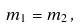Convert formula to latex. <formula><loc_0><loc_0><loc_500><loc_500>m _ { 1 } = m _ { 2 } \, ,</formula> 